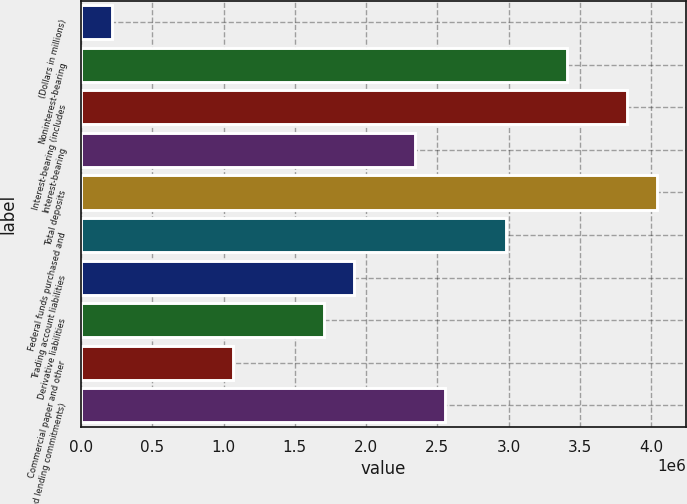Convert chart to OTSL. <chart><loc_0><loc_0><loc_500><loc_500><bar_chart><fcel>(Dollars in millions)<fcel>Noninterest-bearing<fcel>Interest-bearing (includes<fcel>Interest-bearing<fcel>Total deposits<fcel>Federal funds purchased and<fcel>Trading account liabilities<fcel>Derivative liabilities<fcel>Commercial paper and other<fcel>unfunded lending commitments)<nl><fcel>213909<fcel>3.4058e+06<fcel>3.83139e+06<fcel>2.34184e+06<fcel>4.04418e+06<fcel>2.98022e+06<fcel>1.91625e+06<fcel>1.70346e+06<fcel>1.06508e+06<fcel>2.55463e+06<nl></chart> 